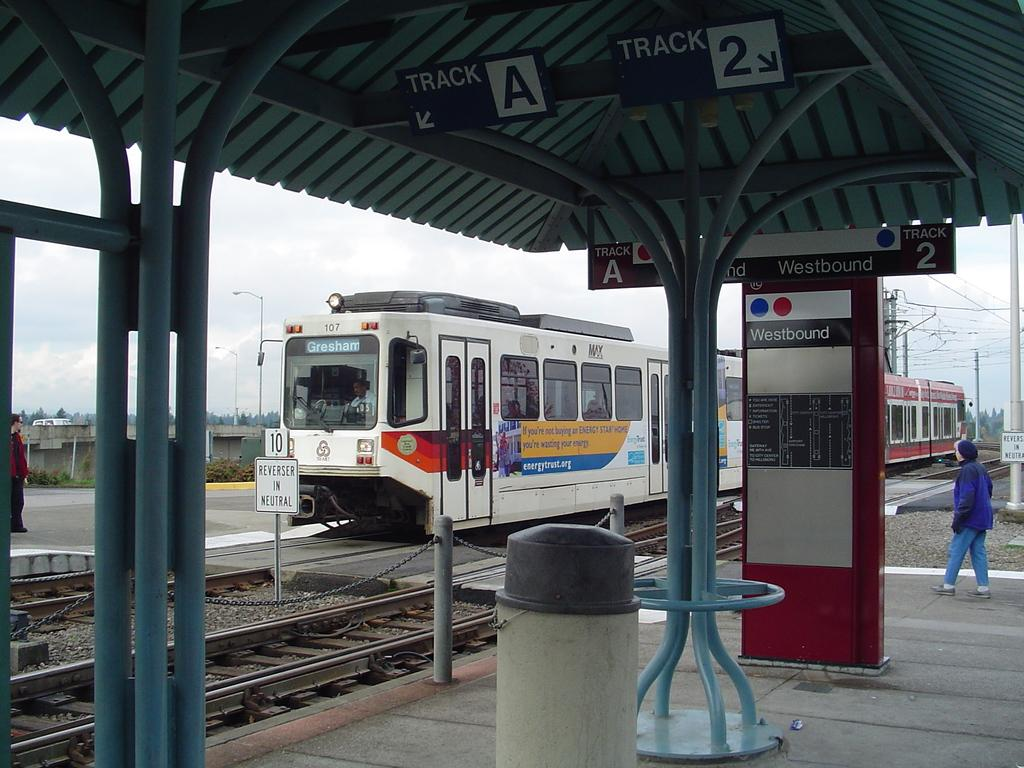<image>
Relay a brief, clear account of the picture shown. A train approaches a platform which has the word Westbound on a sign on the wall. 